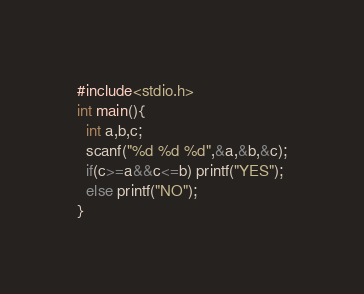<code> <loc_0><loc_0><loc_500><loc_500><_C_>#include<stdio.h>
int main(){
  int a,b,c;
  scanf("%d %d %d",&a,&b,&c);
  if(c>=a&&c<=b) printf("YES");
  else printf("NO");
}</code> 